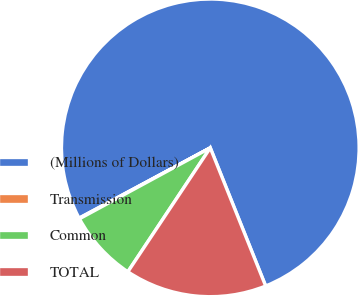Convert chart to OTSL. <chart><loc_0><loc_0><loc_500><loc_500><pie_chart><fcel>(Millions of Dollars)<fcel>Transmission<fcel>Common<fcel>TOTAL<nl><fcel>76.76%<fcel>0.08%<fcel>7.75%<fcel>15.41%<nl></chart> 